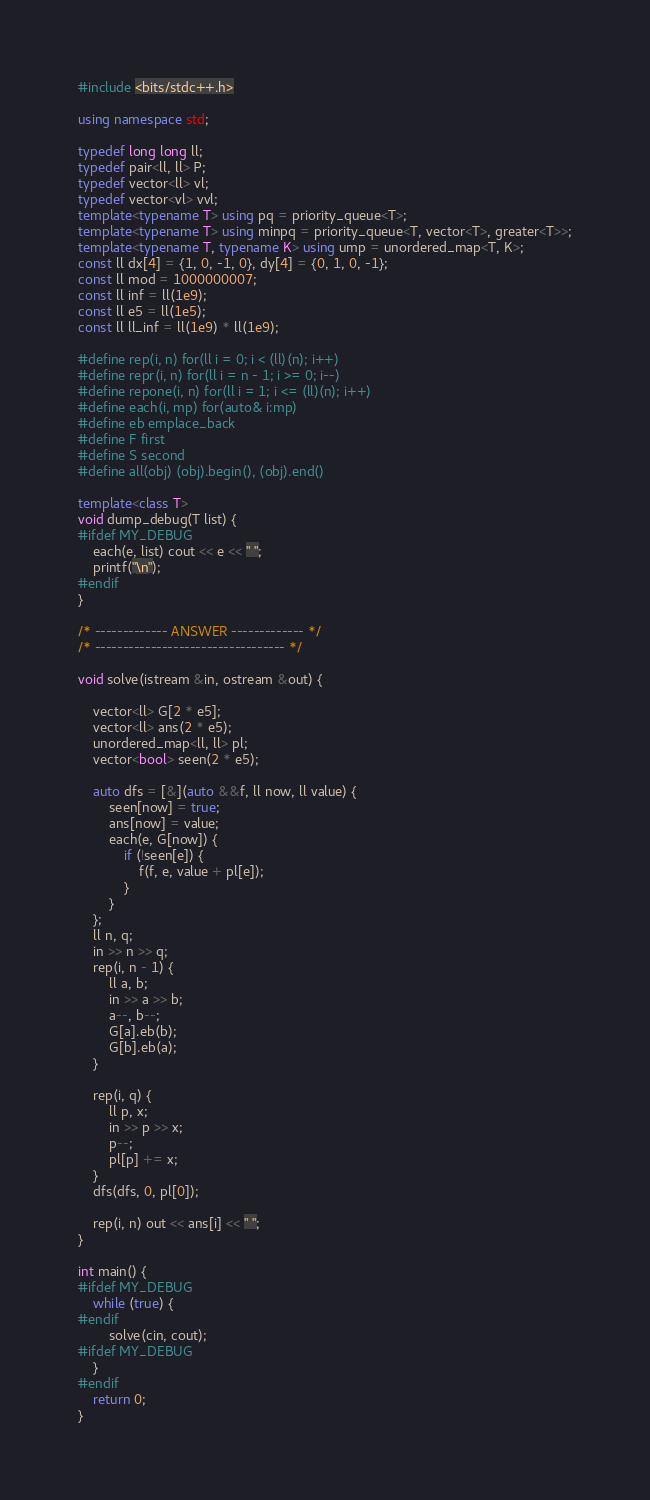Convert code to text. <code><loc_0><loc_0><loc_500><loc_500><_C++_>#include <bits/stdc++.h>

using namespace std;

typedef long long ll;
typedef pair<ll, ll> P;
typedef vector<ll> vl;
typedef vector<vl> vvl;
template<typename T> using pq = priority_queue<T>;
template<typename T> using minpq = priority_queue<T, vector<T>, greater<T>>;
template<typename T, typename K> using ump = unordered_map<T, K>;
const ll dx[4] = {1, 0, -1, 0}, dy[4] = {0, 1, 0, -1};
const ll mod = 1000000007;
const ll inf = ll(1e9);
const ll e5 = ll(1e5);
const ll ll_inf = ll(1e9) * ll(1e9);

#define rep(i, n) for(ll i = 0; i < (ll)(n); i++)
#define repr(i, n) for(ll i = n - 1; i >= 0; i--)
#define repone(i, n) for(ll i = 1; i <= (ll)(n); i++)
#define each(i, mp) for(auto& i:mp)
#define eb emplace_back
#define F first
#define S second
#define all(obj) (obj).begin(), (obj).end()

template<class T>
void dump_debug(T list) {
#ifdef MY_DEBUG
    each(e, list) cout << e << " ";
    printf("\n");
#endif
}

/* ------------- ANSWER ------------- */
/* ---------------------------------- */

void solve(istream &in, ostream &out) {

    vector<ll> G[2 * e5];
    vector<ll> ans(2 * e5);
    unordered_map<ll, ll> pl;
    vector<bool> seen(2 * e5);

    auto dfs = [&](auto &&f, ll now, ll value) {
        seen[now] = true;
        ans[now] = value;
        each(e, G[now]) {
            if (!seen[e]) {
                f(f, e, value + pl[e]);
            }
        }
    };
    ll n, q;
    in >> n >> q;
    rep(i, n - 1) {
        ll a, b;
        in >> a >> b;
        a--, b--;
        G[a].eb(b);
        G[b].eb(a);
    }

    rep(i, q) {
        ll p, x;
        in >> p >> x;
        p--;
        pl[p] += x;
    }
    dfs(dfs, 0, pl[0]);

    rep(i, n) out << ans[i] << " ";
}

int main() {
#ifdef MY_DEBUG
    while (true) {
#endif
        solve(cin, cout);
#ifdef MY_DEBUG
    }
#endif
    return 0;
}</code> 